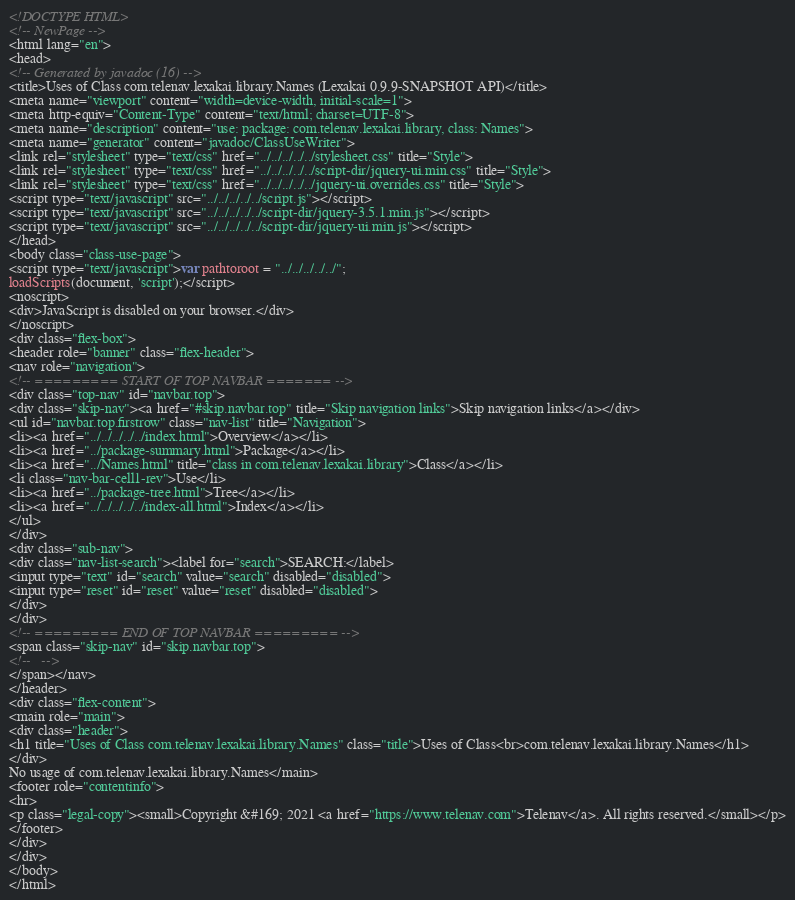Convert code to text. <code><loc_0><loc_0><loc_500><loc_500><_HTML_><!DOCTYPE HTML>
<!-- NewPage -->
<html lang="en">
<head>
<!-- Generated by javadoc (16) -->
<title>Uses of Class com.telenav.lexakai.library.Names (Lexakai 0.9.9-SNAPSHOT API)</title>
<meta name="viewport" content="width=device-width, initial-scale=1">
<meta http-equiv="Content-Type" content="text/html; charset=UTF-8">
<meta name="description" content="use: package: com.telenav.lexakai.library, class: Names">
<meta name="generator" content="javadoc/ClassUseWriter">
<link rel="stylesheet" type="text/css" href="../../../../../stylesheet.css" title="Style">
<link rel="stylesheet" type="text/css" href="../../../../../script-dir/jquery-ui.min.css" title="Style">
<link rel="stylesheet" type="text/css" href="../../../../../jquery-ui.overrides.css" title="Style">
<script type="text/javascript" src="../../../../../script.js"></script>
<script type="text/javascript" src="../../../../../script-dir/jquery-3.5.1.min.js"></script>
<script type="text/javascript" src="../../../../../script-dir/jquery-ui.min.js"></script>
</head>
<body class="class-use-page">
<script type="text/javascript">var pathtoroot = "../../../../../";
loadScripts(document, 'script');</script>
<noscript>
<div>JavaScript is disabled on your browser.</div>
</noscript>
<div class="flex-box">
<header role="banner" class="flex-header">
<nav role="navigation">
<!-- ========= START OF TOP NAVBAR ======= -->
<div class="top-nav" id="navbar.top">
<div class="skip-nav"><a href="#skip.navbar.top" title="Skip navigation links">Skip navigation links</a></div>
<ul id="navbar.top.firstrow" class="nav-list" title="Navigation">
<li><a href="../../../../../index.html">Overview</a></li>
<li><a href="../package-summary.html">Package</a></li>
<li><a href="../Names.html" title="class in com.telenav.lexakai.library">Class</a></li>
<li class="nav-bar-cell1-rev">Use</li>
<li><a href="../package-tree.html">Tree</a></li>
<li><a href="../../../../../index-all.html">Index</a></li>
</ul>
</div>
<div class="sub-nav">
<div class="nav-list-search"><label for="search">SEARCH:</label>
<input type="text" id="search" value="search" disabled="disabled">
<input type="reset" id="reset" value="reset" disabled="disabled">
</div>
</div>
<!-- ========= END OF TOP NAVBAR ========= -->
<span class="skip-nav" id="skip.navbar.top">
<!--   -->
</span></nav>
</header>
<div class="flex-content">
<main role="main">
<div class="header">
<h1 title="Uses of Class com.telenav.lexakai.library.Names" class="title">Uses of Class<br>com.telenav.lexakai.library.Names</h1>
</div>
No usage of com.telenav.lexakai.library.Names</main>
<footer role="contentinfo">
<hr>
<p class="legal-copy"><small>Copyright &#169; 2021 <a href="https://www.telenav.com">Telenav</a>. All rights reserved.</small></p>
</footer>
</div>
</div>
</body>
</html>
</code> 